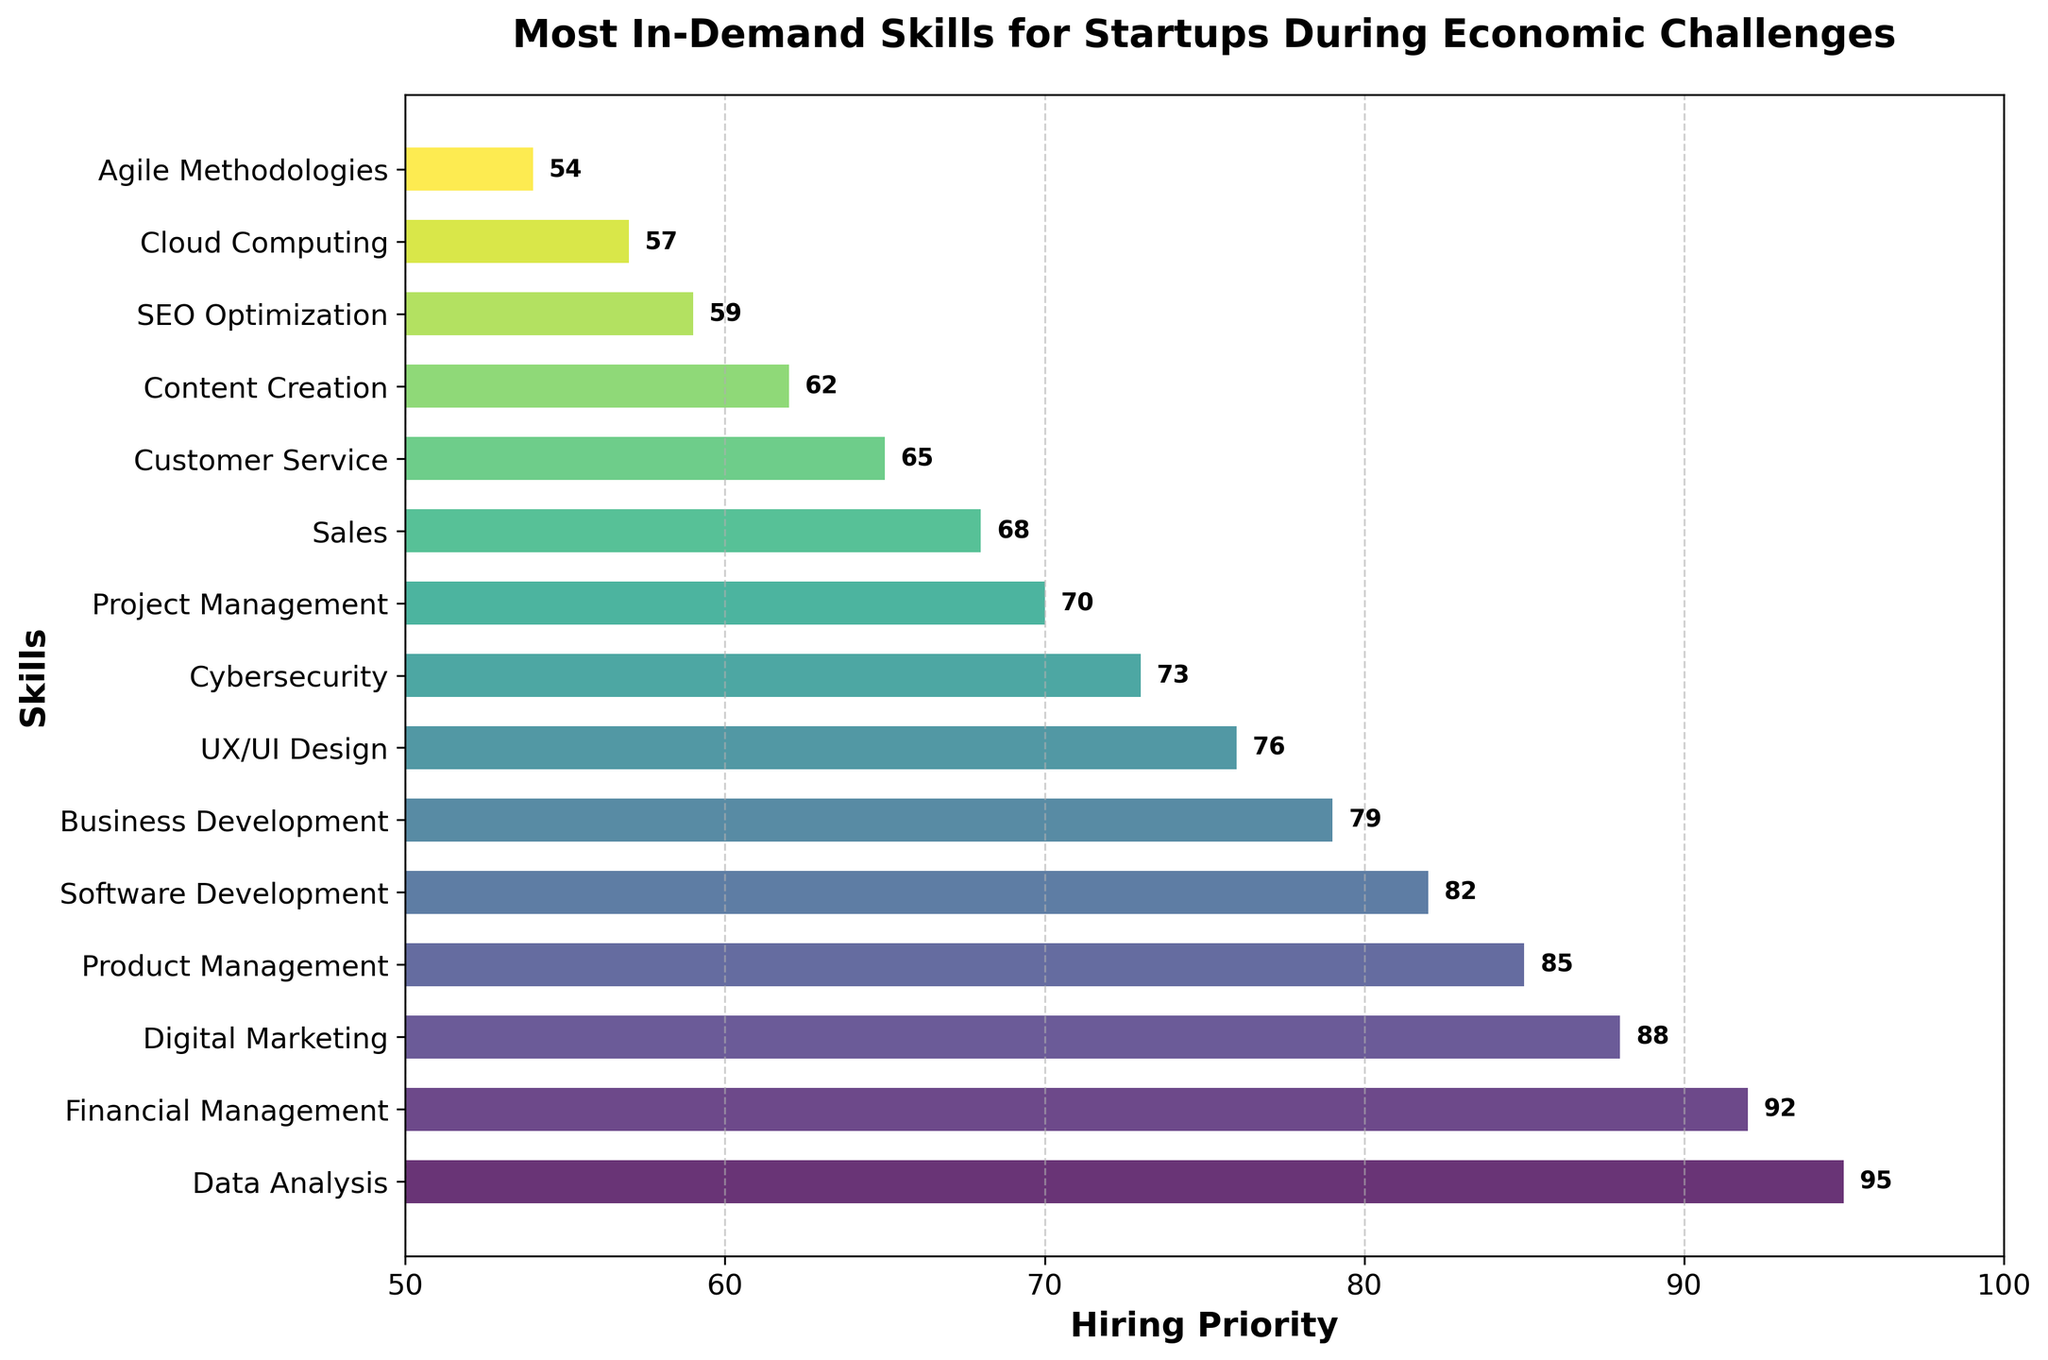Which skill is ranked highest in hiring priority? The bar representing "Data Analysis" extends the furthest to the right, indicating it has the highest hiring priority.
Answer: Data Analysis Which two skills have a hiring priority of less than 60? The bars for "SEO Optimization" and "Cloud Computing" both extend to values slightly below 60 on the hiring priority axis.
Answer: SEO Optimization, Cloud Computing What is the difference in hiring priority between Digital Marketing and UX/UI Design? The hiring priority for "Digital Marketing" is 88, and for "UX/UI Design" it is 76. Subtracting these values gives the difference: 88 - 76 = 12.
Answer: 12 Which skill has a higher hiring priority, Business Development or Software Development? The bar for "Software Development" extends further to the right (82) compared to the bar for "Business Development" (79).
Answer: Software Development What is the average hiring priority of Customer Service and Content Creation? The hiring priority for "Customer Service" is 65, and for "Content Creation" it is 62. Adding these values and dividing by 2 gives the average: (65 + 62) / 2 = 63.5.
Answer: 63.5 Which skills have a hiring priority within the range of 70 to 80? The bars that extend within the 70 to 80 range are "Project Management" (70) and "Business Development" (79).
Answer: Project Management, Business Development Between Financial Management and Product Management, which one has a lower hiring priority and by how much? The hiring priority for "Financial Management" is 92, and for "Product Management" it is 85. The difference is 92 - 85 = 7.
Answer: Product Management, 7 What is the total hiring priority of the top 3 skills? The top three skills are "Data Analysis" (95), "Financial Management" (92), and "Digital Marketing" (88). Adding these values gives: 95 + 92 + 88 = 275.
Answer: 275 Which skill has the lowest hiring priority and what is its value? The bar for "Agile Methodologies" extends the least to the right, indicating it has the lowest hiring priority with a value of 54.
Answer: Agile Methodologies, 54 